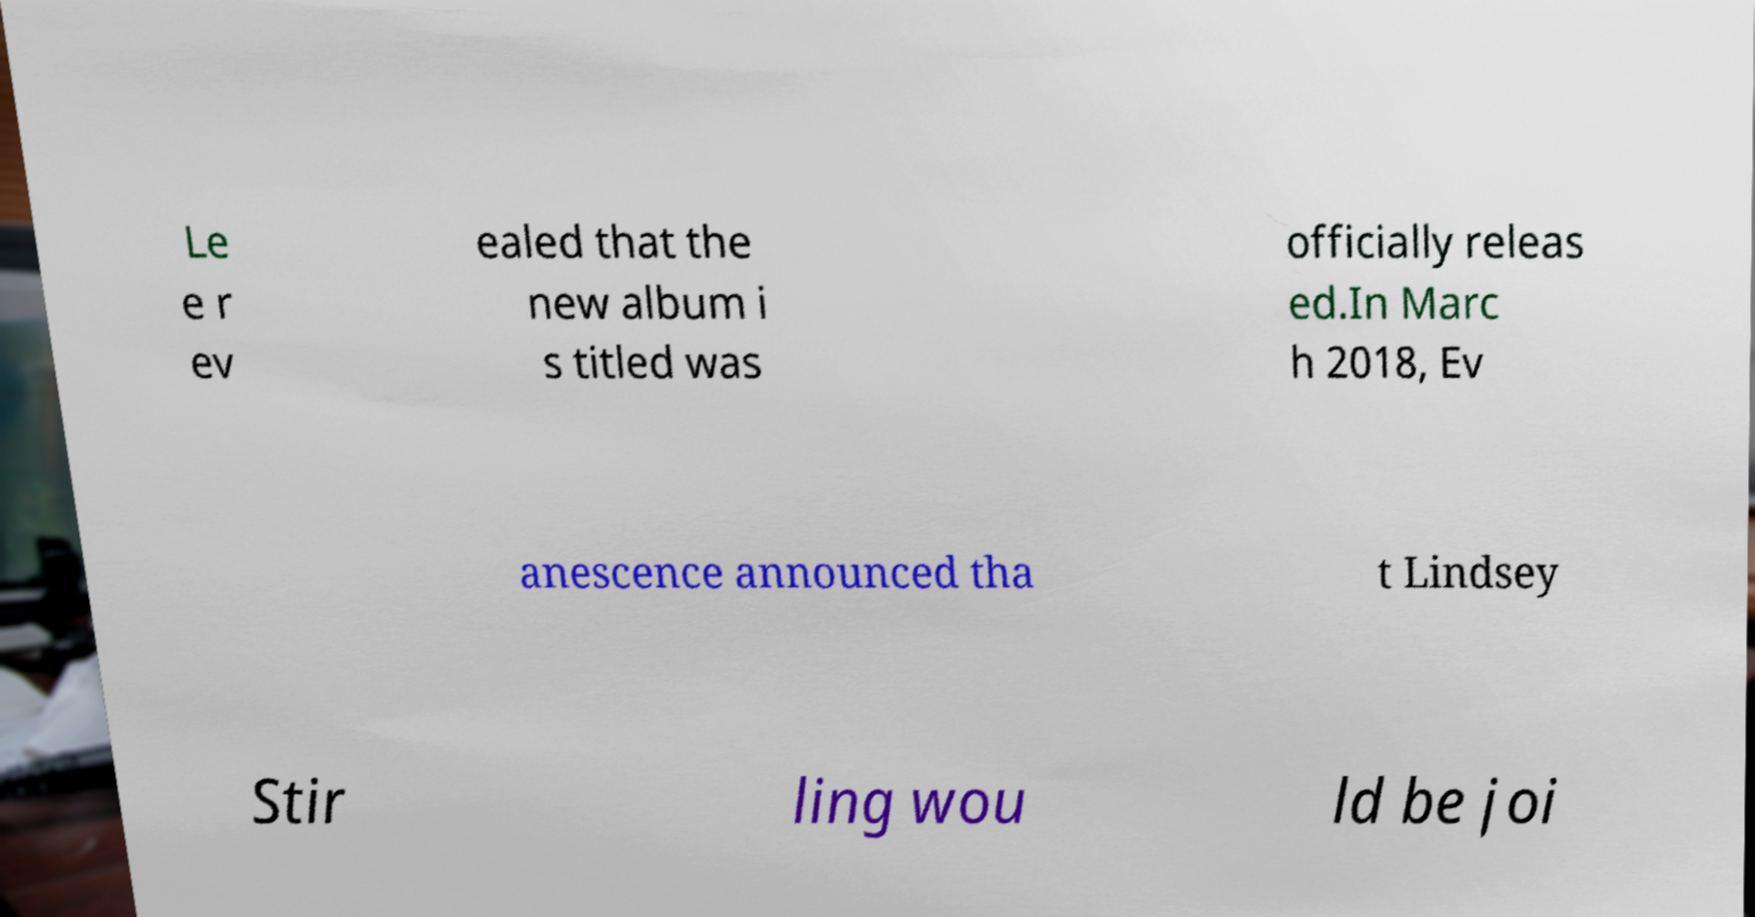Could you assist in decoding the text presented in this image and type it out clearly? Le e r ev ealed that the new album i s titled was officially releas ed.In Marc h 2018, Ev anescence announced tha t Lindsey Stir ling wou ld be joi 